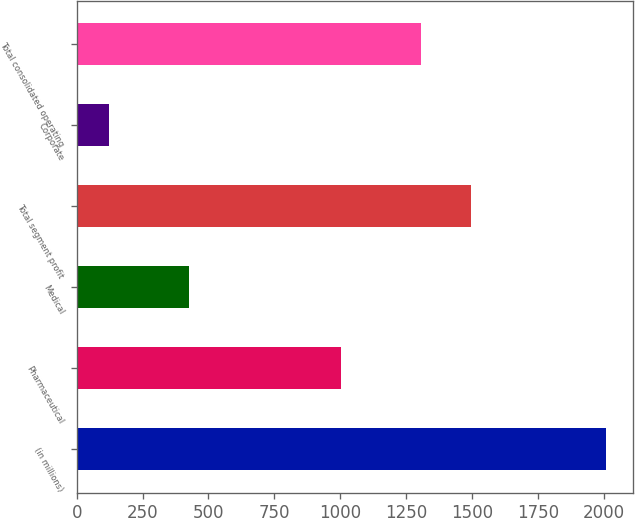Convert chart to OTSL. <chart><loc_0><loc_0><loc_500><loc_500><bar_chart><fcel>(in millions)<fcel>Pharmaceutical<fcel>Medical<fcel>Total segment profit<fcel>Corporate<fcel>Total consolidated operating<nl><fcel>2010<fcel>1001.8<fcel>427.7<fcel>1495.64<fcel>122.6<fcel>1306.9<nl></chart> 